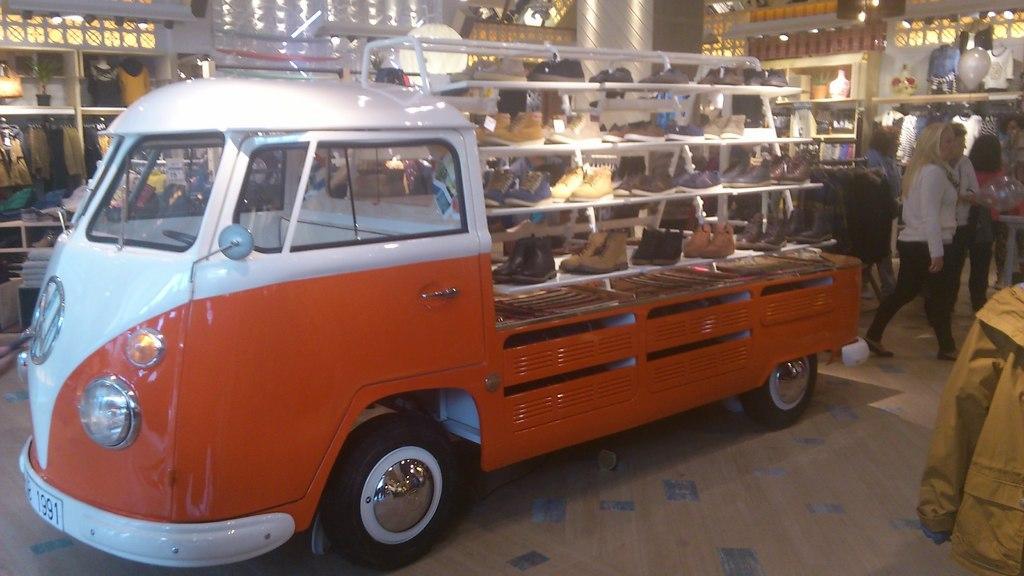Describe this image in one or two sentences. In this picture there is a vehicle in the center of the image, on which there are foot wear and there are people on the right side of the image, there are cracks on the right and left side of the image. 